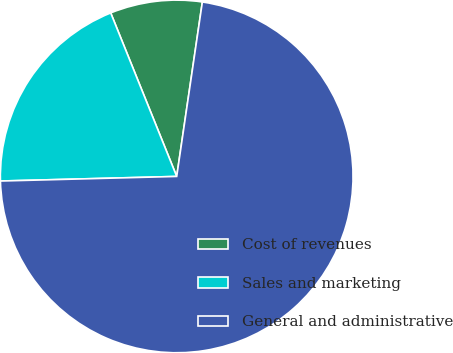Convert chart to OTSL. <chart><loc_0><loc_0><loc_500><loc_500><pie_chart><fcel>Cost of revenues<fcel>Sales and marketing<fcel>General and administrative<nl><fcel>8.43%<fcel>19.31%<fcel>72.26%<nl></chart> 